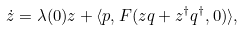Convert formula to latex. <formula><loc_0><loc_0><loc_500><loc_500>\dot { z } = \lambda ( 0 ) z + \langle p , F ( z q + z ^ { \dag } q ^ { \dag } , 0 ) \rangle ,</formula> 